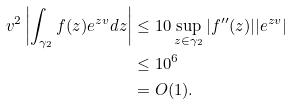<formula> <loc_0><loc_0><loc_500><loc_500>v ^ { 2 } \left | \int _ { \gamma _ { 2 } } f ( z ) e ^ { z v } d z \right | & \leq 1 0 \sup _ { z \in \gamma _ { 2 } } | f ^ { \prime \prime } ( z ) | | e ^ { z v } | \\ & \leq 1 0 ^ { 6 } \\ & = O ( 1 ) .</formula> 